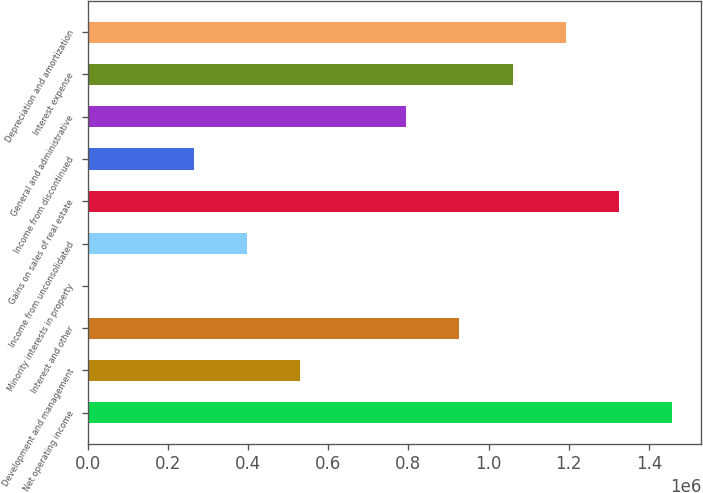Convert chart to OTSL. <chart><loc_0><loc_0><loc_500><loc_500><bar_chart><fcel>Net operating income<fcel>Development and management<fcel>Interest and other<fcel>Minority interests in property<fcel>Income from unconsolidated<fcel>Gains on sales of real estate<fcel>Income from discontinued<fcel>General and administrative<fcel>Interest expense<fcel>Depreciation and amortization<nl><fcel>1.45715e+06<fcel>529926<fcel>927308<fcel>84<fcel>397466<fcel>1.32469e+06<fcel>265005<fcel>794848<fcel>1.05977e+06<fcel>1.19223e+06<nl></chart> 